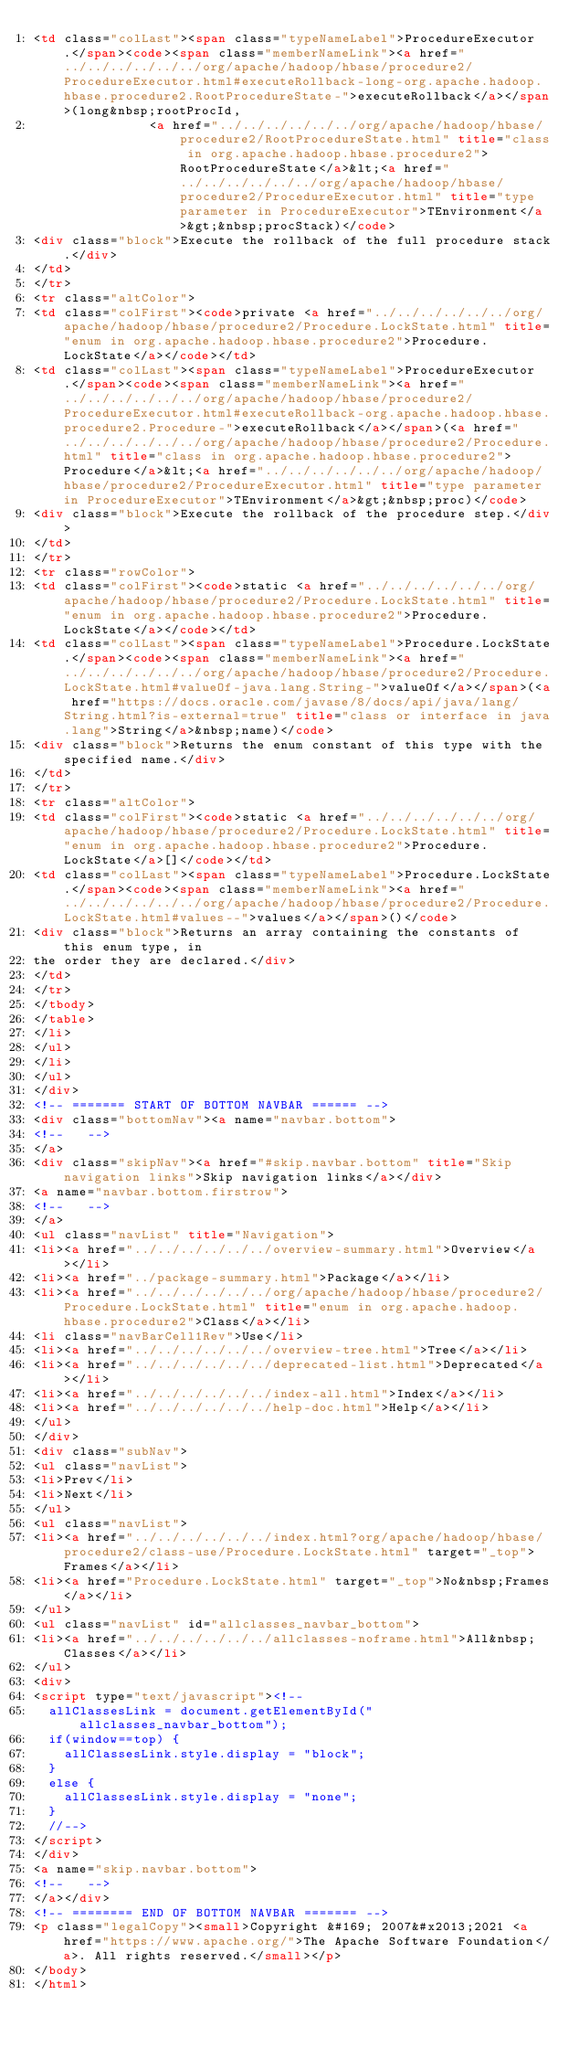<code> <loc_0><loc_0><loc_500><loc_500><_HTML_><td class="colLast"><span class="typeNameLabel">ProcedureExecutor.</span><code><span class="memberNameLink"><a href="../../../../../../org/apache/hadoop/hbase/procedure2/ProcedureExecutor.html#executeRollback-long-org.apache.hadoop.hbase.procedure2.RootProcedureState-">executeRollback</a></span>(long&nbsp;rootProcId,
               <a href="../../../../../../org/apache/hadoop/hbase/procedure2/RootProcedureState.html" title="class in org.apache.hadoop.hbase.procedure2">RootProcedureState</a>&lt;<a href="../../../../../../org/apache/hadoop/hbase/procedure2/ProcedureExecutor.html" title="type parameter in ProcedureExecutor">TEnvironment</a>&gt;&nbsp;procStack)</code>
<div class="block">Execute the rollback of the full procedure stack.</div>
</td>
</tr>
<tr class="altColor">
<td class="colFirst"><code>private <a href="../../../../../../org/apache/hadoop/hbase/procedure2/Procedure.LockState.html" title="enum in org.apache.hadoop.hbase.procedure2">Procedure.LockState</a></code></td>
<td class="colLast"><span class="typeNameLabel">ProcedureExecutor.</span><code><span class="memberNameLink"><a href="../../../../../../org/apache/hadoop/hbase/procedure2/ProcedureExecutor.html#executeRollback-org.apache.hadoop.hbase.procedure2.Procedure-">executeRollback</a></span>(<a href="../../../../../../org/apache/hadoop/hbase/procedure2/Procedure.html" title="class in org.apache.hadoop.hbase.procedure2">Procedure</a>&lt;<a href="../../../../../../org/apache/hadoop/hbase/procedure2/ProcedureExecutor.html" title="type parameter in ProcedureExecutor">TEnvironment</a>&gt;&nbsp;proc)</code>
<div class="block">Execute the rollback of the procedure step.</div>
</td>
</tr>
<tr class="rowColor">
<td class="colFirst"><code>static <a href="../../../../../../org/apache/hadoop/hbase/procedure2/Procedure.LockState.html" title="enum in org.apache.hadoop.hbase.procedure2">Procedure.LockState</a></code></td>
<td class="colLast"><span class="typeNameLabel">Procedure.LockState.</span><code><span class="memberNameLink"><a href="../../../../../../org/apache/hadoop/hbase/procedure2/Procedure.LockState.html#valueOf-java.lang.String-">valueOf</a></span>(<a href="https://docs.oracle.com/javase/8/docs/api/java/lang/String.html?is-external=true" title="class or interface in java.lang">String</a>&nbsp;name)</code>
<div class="block">Returns the enum constant of this type with the specified name.</div>
</td>
</tr>
<tr class="altColor">
<td class="colFirst"><code>static <a href="../../../../../../org/apache/hadoop/hbase/procedure2/Procedure.LockState.html" title="enum in org.apache.hadoop.hbase.procedure2">Procedure.LockState</a>[]</code></td>
<td class="colLast"><span class="typeNameLabel">Procedure.LockState.</span><code><span class="memberNameLink"><a href="../../../../../../org/apache/hadoop/hbase/procedure2/Procedure.LockState.html#values--">values</a></span>()</code>
<div class="block">Returns an array containing the constants of this enum type, in
the order they are declared.</div>
</td>
</tr>
</tbody>
</table>
</li>
</ul>
</li>
</ul>
</div>
<!-- ======= START OF BOTTOM NAVBAR ====== -->
<div class="bottomNav"><a name="navbar.bottom">
<!--   -->
</a>
<div class="skipNav"><a href="#skip.navbar.bottom" title="Skip navigation links">Skip navigation links</a></div>
<a name="navbar.bottom.firstrow">
<!--   -->
</a>
<ul class="navList" title="Navigation">
<li><a href="../../../../../../overview-summary.html">Overview</a></li>
<li><a href="../package-summary.html">Package</a></li>
<li><a href="../../../../../../org/apache/hadoop/hbase/procedure2/Procedure.LockState.html" title="enum in org.apache.hadoop.hbase.procedure2">Class</a></li>
<li class="navBarCell1Rev">Use</li>
<li><a href="../../../../../../overview-tree.html">Tree</a></li>
<li><a href="../../../../../../deprecated-list.html">Deprecated</a></li>
<li><a href="../../../../../../index-all.html">Index</a></li>
<li><a href="../../../../../../help-doc.html">Help</a></li>
</ul>
</div>
<div class="subNav">
<ul class="navList">
<li>Prev</li>
<li>Next</li>
</ul>
<ul class="navList">
<li><a href="../../../../../../index.html?org/apache/hadoop/hbase/procedure2/class-use/Procedure.LockState.html" target="_top">Frames</a></li>
<li><a href="Procedure.LockState.html" target="_top">No&nbsp;Frames</a></li>
</ul>
<ul class="navList" id="allclasses_navbar_bottom">
<li><a href="../../../../../../allclasses-noframe.html">All&nbsp;Classes</a></li>
</ul>
<div>
<script type="text/javascript"><!--
  allClassesLink = document.getElementById("allclasses_navbar_bottom");
  if(window==top) {
    allClassesLink.style.display = "block";
  }
  else {
    allClassesLink.style.display = "none";
  }
  //-->
</script>
</div>
<a name="skip.navbar.bottom">
<!--   -->
</a></div>
<!-- ======== END OF BOTTOM NAVBAR ======= -->
<p class="legalCopy"><small>Copyright &#169; 2007&#x2013;2021 <a href="https://www.apache.org/">The Apache Software Foundation</a>. All rights reserved.</small></p>
</body>
</html>
</code> 